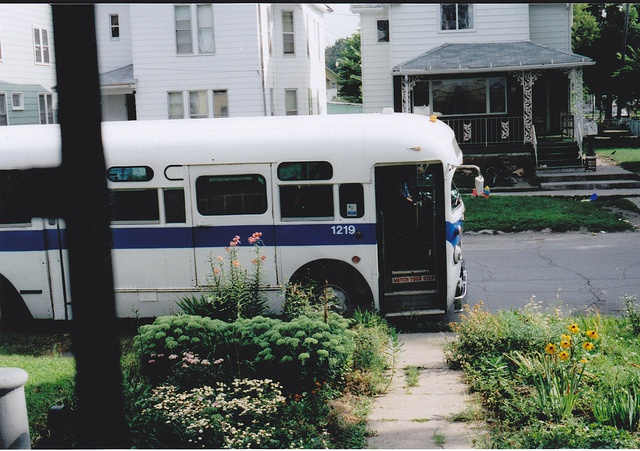Describe the objects in this image and their specific colors. I can see bus in black, darkgray, lightgray, and navy tones in this image. 